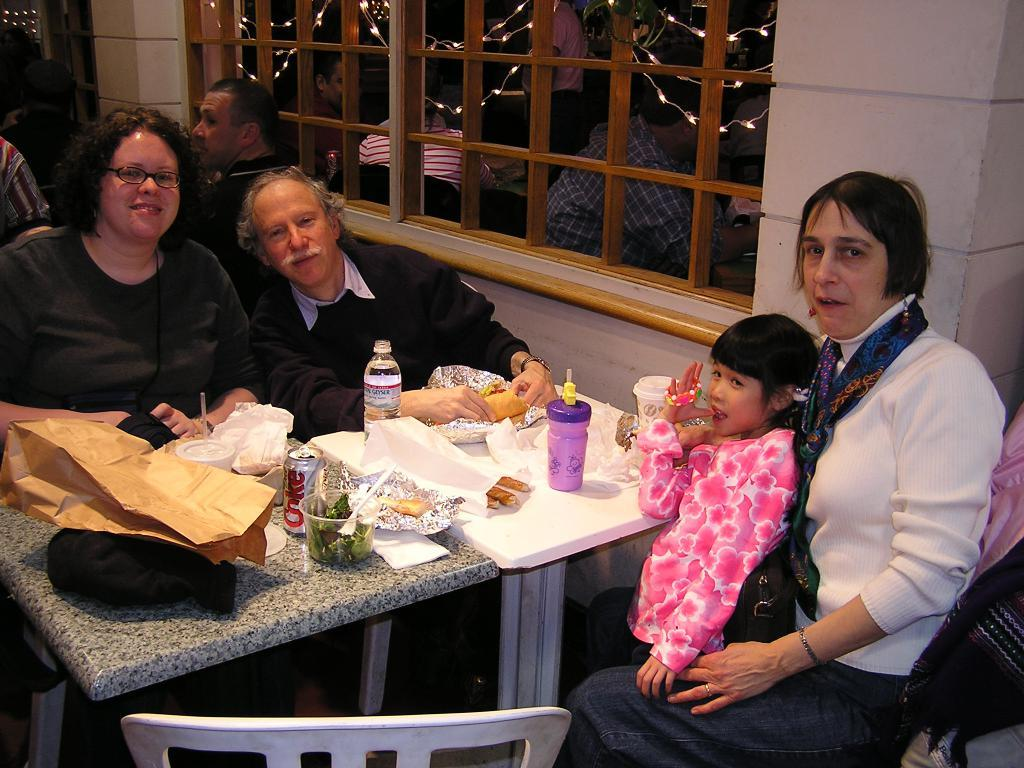What is happening in the image involving a group of people? There is a group of people in the image, and they are seated on chairs. What is present on the table in the image? There is food and bottles on the table in the image. What type of vase is present on the table in the image? There is no vase present on the table in the image. What feeling do the people in the image seem to be experiencing? The image does not provide any information about the feelings of the people in the image. 